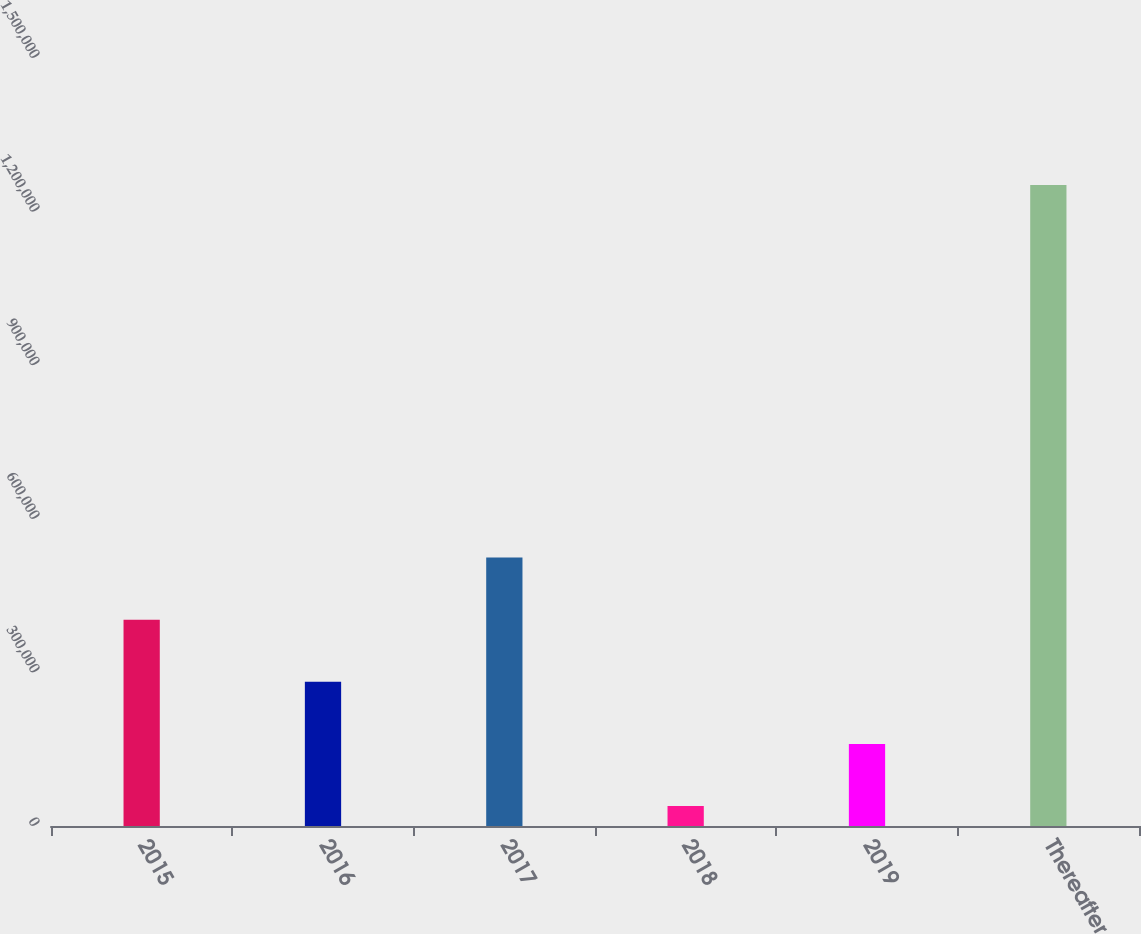<chart> <loc_0><loc_0><loc_500><loc_500><bar_chart><fcel>2015<fcel>2016<fcel>2017<fcel>2018<fcel>2019<fcel>Thereafter<nl><fcel>402877<fcel>281558<fcel>524196<fcel>38920<fcel>160239<fcel>1.25211e+06<nl></chart> 